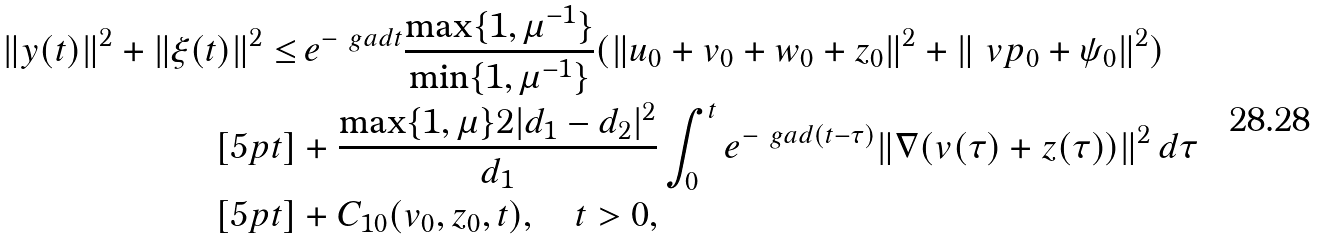<formula> <loc_0><loc_0><loc_500><loc_500>\| y ( t ) \| ^ { 2 } + \| \xi ( t ) \| ^ { 2 } \leq & \, e ^ { - \ g a d t } \frac { \max \{ 1 , \mu ^ { - 1 } \} } { \min \{ 1 , \mu ^ { - 1 } \} } ( \| u _ { 0 } + v _ { 0 } + w _ { 0 } + z _ { 0 } \| ^ { 2 } + \| \ v p _ { 0 } + \psi _ { 0 } \| ^ { 2 } ) \\ [ 5 p t ] & + \frac { \max \{ 1 , \mu \} 2 | d _ { 1 } - d _ { 2 } | ^ { 2 } } { d _ { 1 } } \int _ { 0 } ^ { t } e ^ { - \ g a d ( t - \tau ) } \| \nabla ( v ( \tau ) + z ( \tau ) ) \| ^ { 2 } \, d \tau \\ [ 5 p t ] & + C _ { 1 0 } ( v _ { 0 } , z _ { 0 } , t ) , \quad t > 0 ,</formula> 